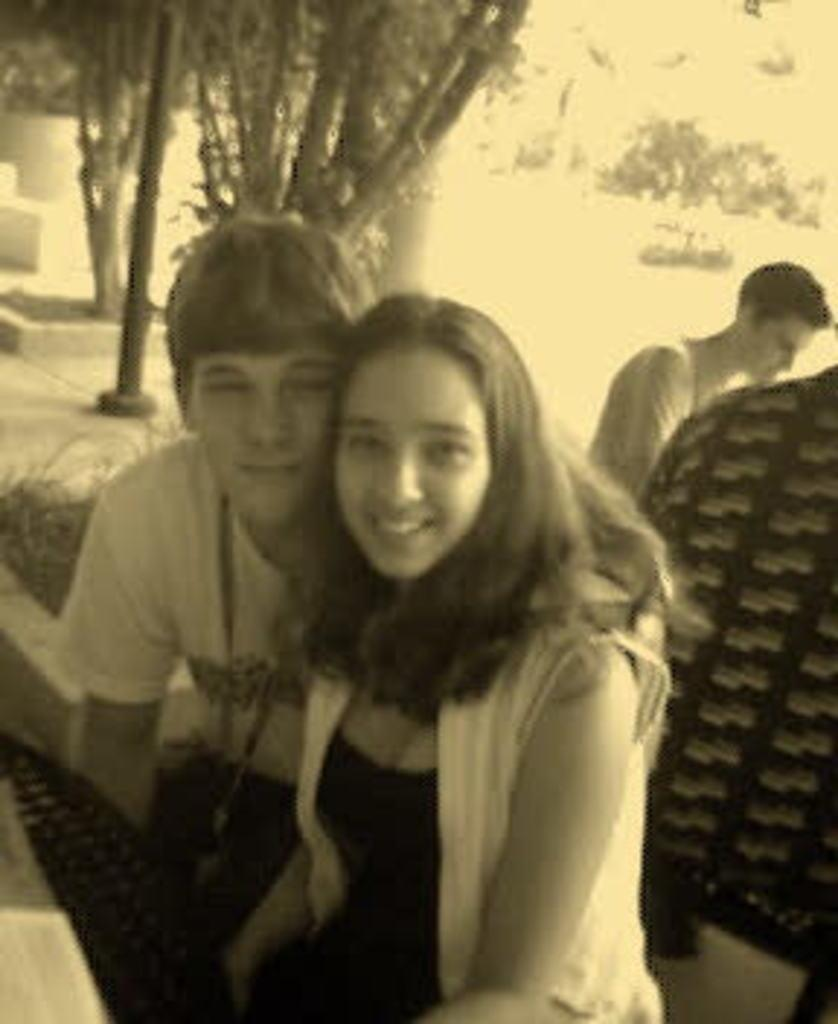What are the people in the image doing? The people in the image are seated. What can be seen in the background of the image? There are trees visible in the image. Can you describe the man in the image? There is a man wearing an ID card in the image. What object is present in the image that is commonly used for typing? A keyboard is present in the image. What type of whistle can be heard in the image? There is no whistle present in the image, and therefore no sound can be heard. 